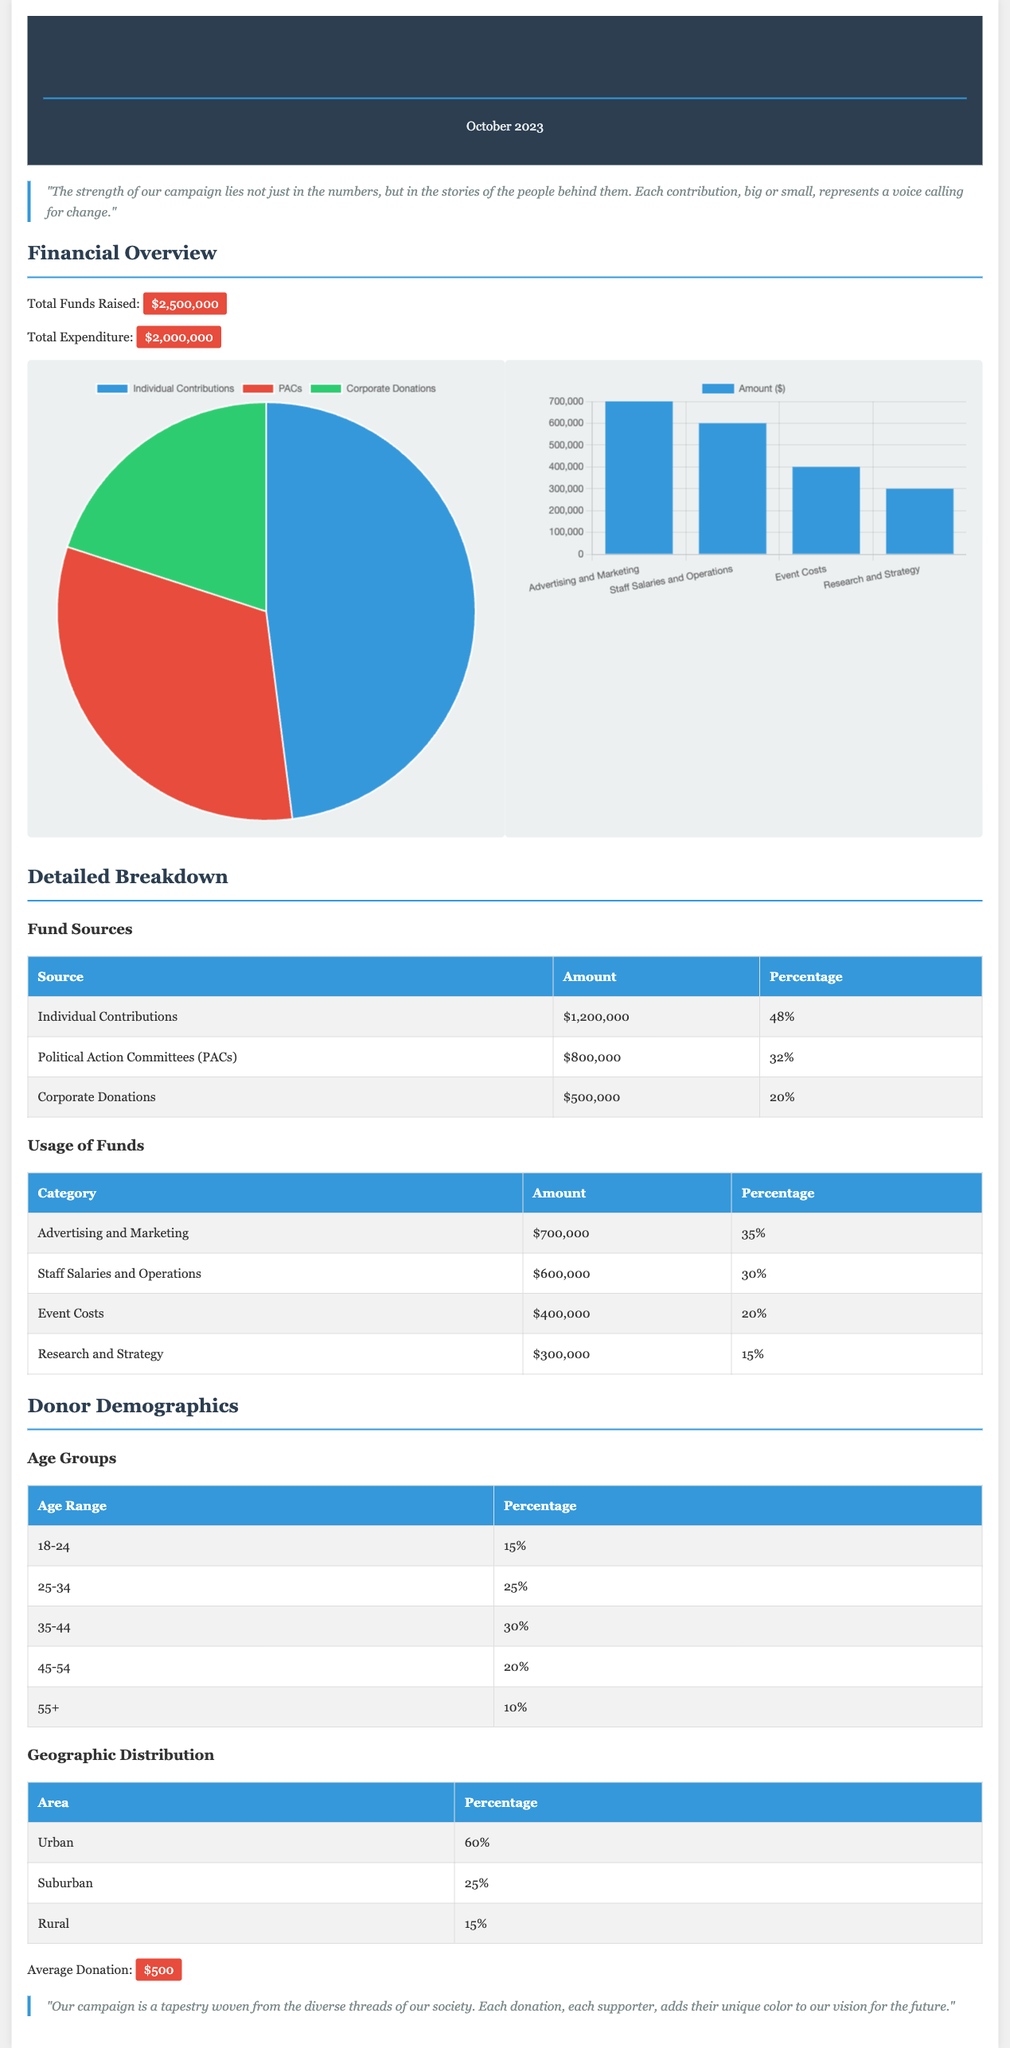What is the total funds raised? The total funds raised is explicitly stated in the report as $2,500,000.
Answer: $2,500,000 What percentage of funds came from Individual Contributions? The report specifies that Individual Contributions account for 48% of the total funds raised.
Answer: 48% How much was spent on Advertising and Marketing? The expenditure breakdown shows that $700,000 was allocated for Advertising and Marketing.
Answer: $700,000 What is the average donation amount? The document mentions that the average donation received is $500.
Answer: $500 What percentage of donors are in the 25-34 age group? The report indicates that 25% of the donors fall within the 25-34 age range.
Answer: 25% Which area contributes the most to fundraising? The Geographic Distribution section states that 60% of the contributions come from Urban areas, making it the largest contributor.
Answer: Urban What is the total expenditure? The document clearly states the total expenditure is $2,000,000.
Answer: $2,000,000 Which category received the least funding? The Usage of Funds table highlights that Research and Strategy received the least funding, with $300,000 allocated.
Answer: Research and Strategy What is the total percentage of funds raised from PACs? According to the Fund Sources section, PACs account for 32% of total funds raised.
Answer: 32% 